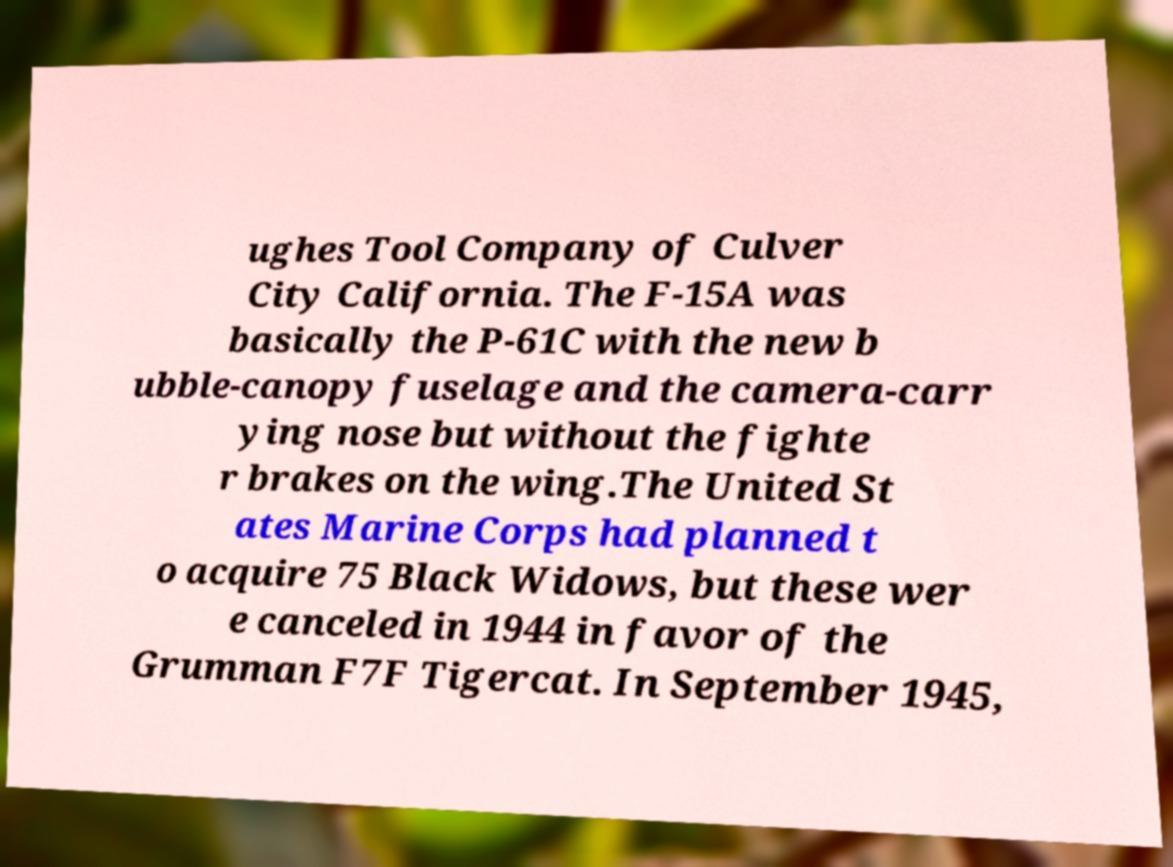Please identify and transcribe the text found in this image. ughes Tool Company of Culver City California. The F-15A was basically the P-61C with the new b ubble-canopy fuselage and the camera-carr ying nose but without the fighte r brakes on the wing.The United St ates Marine Corps had planned t o acquire 75 Black Widows, but these wer e canceled in 1944 in favor of the Grumman F7F Tigercat. In September 1945, 